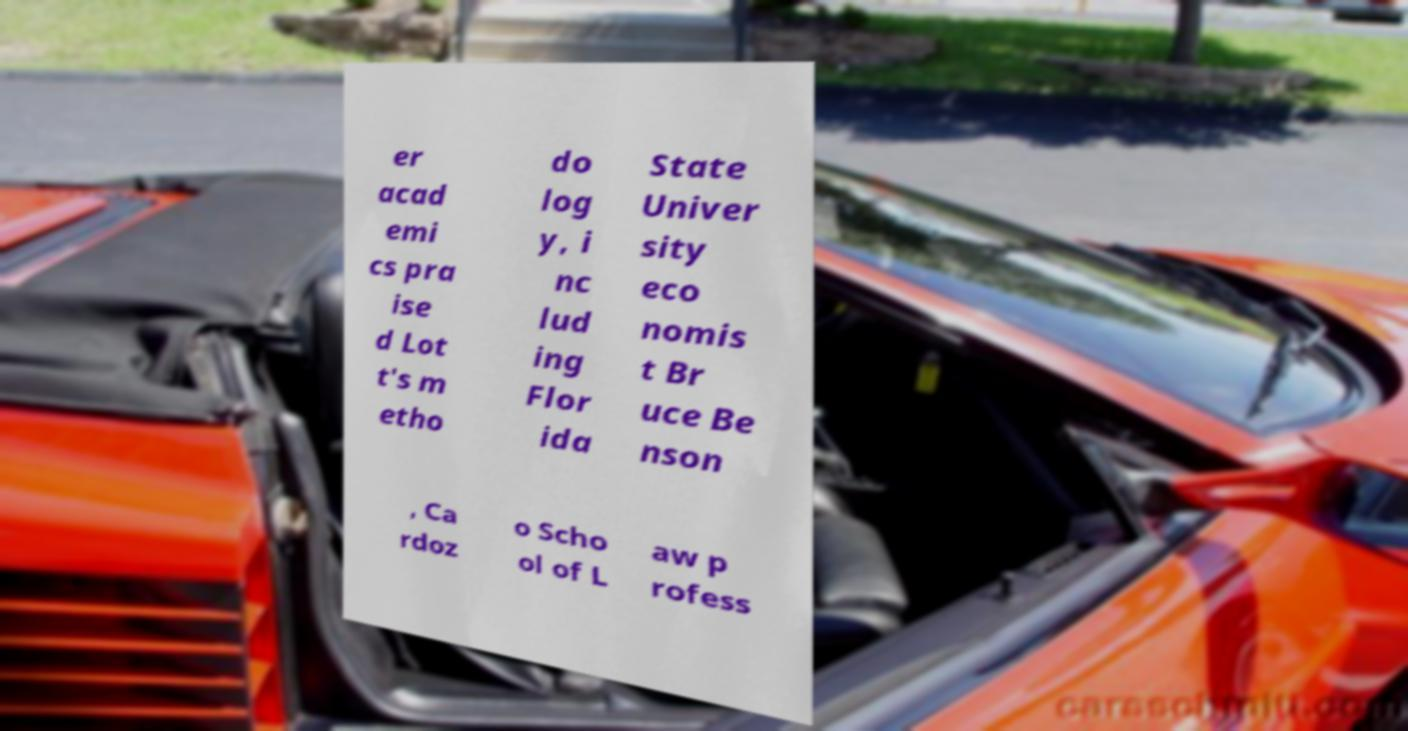Can you accurately transcribe the text from the provided image for me? er acad emi cs pra ise d Lot t's m etho do log y, i nc lud ing Flor ida State Univer sity eco nomis t Br uce Be nson , Ca rdoz o Scho ol of L aw p rofess 